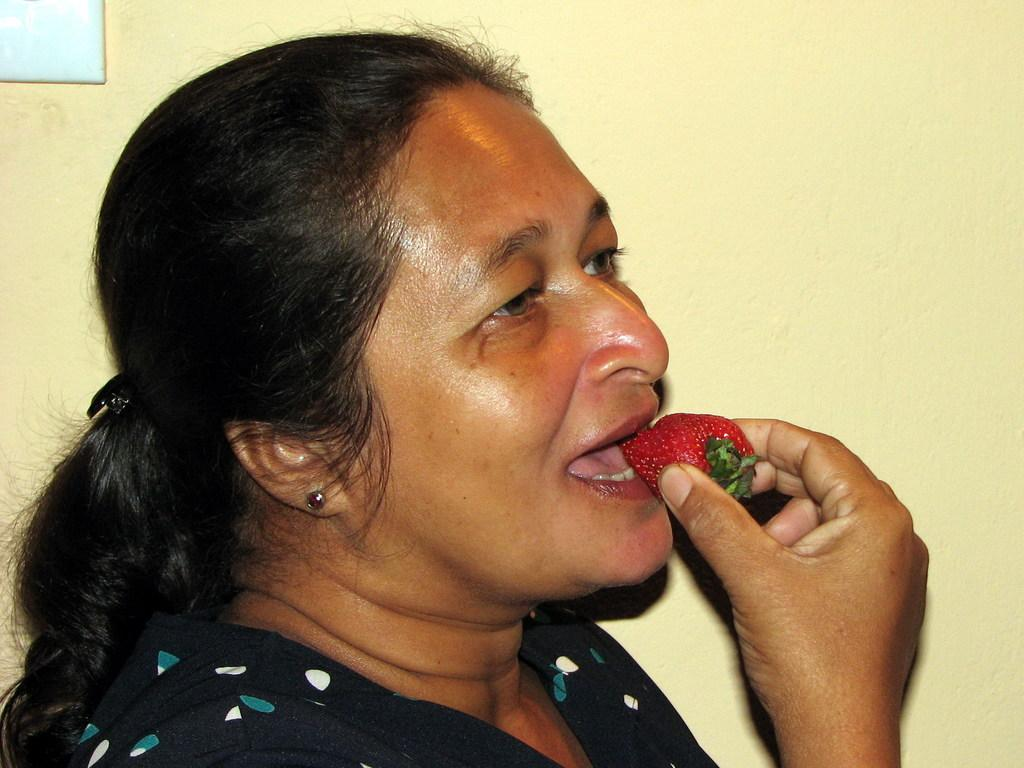Who is the main subject in the image? There is a woman in the image. What is the woman doing in the image? The woman is eating a strawberry. What can be seen in the background of the image? There is a wall in the background of the image. How many pigs are visible in the image? There are no pigs present in the image. What type of structure is the woman standing next to in the image? The provided facts do not mention any structure or building in the image. 